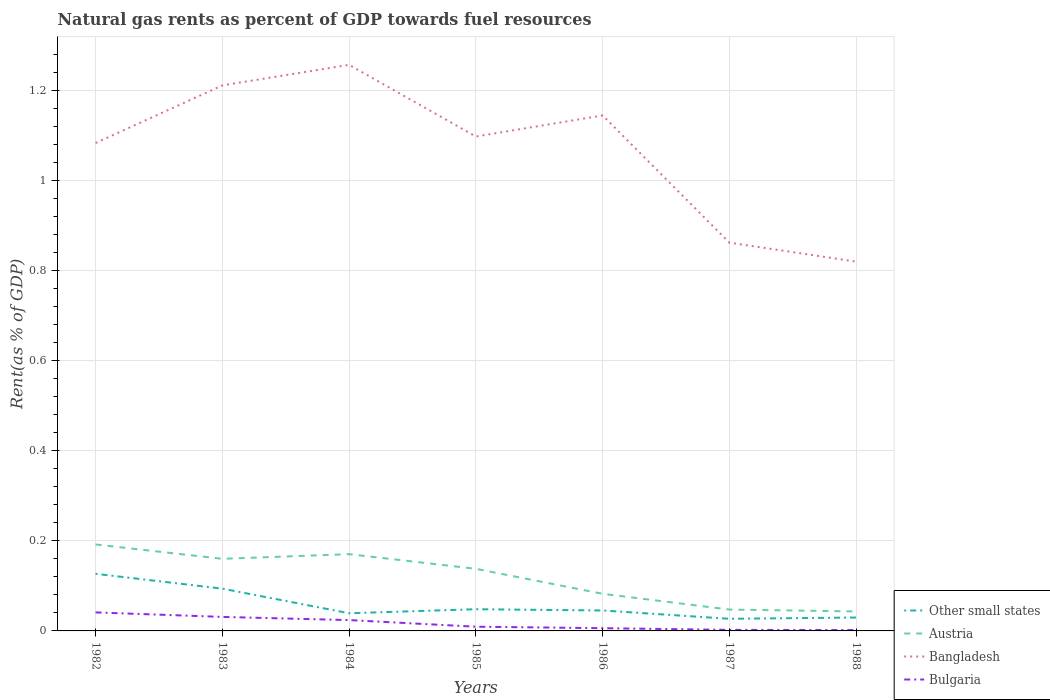Does the line corresponding to Austria intersect with the line corresponding to Bulgaria?
Ensure brevity in your answer.  No. Is the number of lines equal to the number of legend labels?
Your answer should be very brief. Yes. Across all years, what is the maximum matural gas rent in Bulgaria?
Keep it short and to the point. 0. What is the total matural gas rent in Bulgaria in the graph?
Your response must be concise. 0. What is the difference between the highest and the second highest matural gas rent in Other small states?
Offer a very short reply. 0.1. What is the difference between the highest and the lowest matural gas rent in Bangladesh?
Provide a short and direct response. 5. How many lines are there?
Your answer should be compact. 4. Does the graph contain any zero values?
Your answer should be very brief. No. Does the graph contain grids?
Offer a very short reply. Yes. How many legend labels are there?
Your answer should be very brief. 4. What is the title of the graph?
Give a very brief answer. Natural gas rents as percent of GDP towards fuel resources. What is the label or title of the Y-axis?
Ensure brevity in your answer.  Rent(as % of GDP). What is the Rent(as % of GDP) of Other small states in 1982?
Ensure brevity in your answer.  0.13. What is the Rent(as % of GDP) of Austria in 1982?
Provide a succinct answer. 0.19. What is the Rent(as % of GDP) of Bangladesh in 1982?
Offer a very short reply. 1.08. What is the Rent(as % of GDP) of Bulgaria in 1982?
Offer a terse response. 0.04. What is the Rent(as % of GDP) of Other small states in 1983?
Your answer should be very brief. 0.09. What is the Rent(as % of GDP) of Austria in 1983?
Ensure brevity in your answer.  0.16. What is the Rent(as % of GDP) in Bangladesh in 1983?
Keep it short and to the point. 1.21. What is the Rent(as % of GDP) in Bulgaria in 1983?
Keep it short and to the point. 0.03. What is the Rent(as % of GDP) of Other small states in 1984?
Offer a very short reply. 0.04. What is the Rent(as % of GDP) in Austria in 1984?
Provide a succinct answer. 0.17. What is the Rent(as % of GDP) of Bangladesh in 1984?
Your response must be concise. 1.26. What is the Rent(as % of GDP) in Bulgaria in 1984?
Provide a succinct answer. 0.02. What is the Rent(as % of GDP) in Other small states in 1985?
Provide a succinct answer. 0.05. What is the Rent(as % of GDP) of Austria in 1985?
Make the answer very short. 0.14. What is the Rent(as % of GDP) in Bangladesh in 1985?
Keep it short and to the point. 1.1. What is the Rent(as % of GDP) of Bulgaria in 1985?
Ensure brevity in your answer.  0.01. What is the Rent(as % of GDP) in Other small states in 1986?
Your response must be concise. 0.05. What is the Rent(as % of GDP) of Austria in 1986?
Offer a terse response. 0.08. What is the Rent(as % of GDP) of Bangladesh in 1986?
Provide a succinct answer. 1.14. What is the Rent(as % of GDP) of Bulgaria in 1986?
Your answer should be compact. 0.01. What is the Rent(as % of GDP) of Other small states in 1987?
Offer a terse response. 0.03. What is the Rent(as % of GDP) in Austria in 1987?
Keep it short and to the point. 0.05. What is the Rent(as % of GDP) of Bangladesh in 1987?
Your answer should be compact. 0.86. What is the Rent(as % of GDP) of Bulgaria in 1987?
Keep it short and to the point. 0. What is the Rent(as % of GDP) in Other small states in 1988?
Your answer should be compact. 0.03. What is the Rent(as % of GDP) of Austria in 1988?
Your answer should be compact. 0.04. What is the Rent(as % of GDP) of Bangladesh in 1988?
Offer a terse response. 0.82. What is the Rent(as % of GDP) of Bulgaria in 1988?
Offer a very short reply. 0. Across all years, what is the maximum Rent(as % of GDP) in Other small states?
Your response must be concise. 0.13. Across all years, what is the maximum Rent(as % of GDP) in Austria?
Offer a terse response. 0.19. Across all years, what is the maximum Rent(as % of GDP) of Bangladesh?
Offer a very short reply. 1.26. Across all years, what is the maximum Rent(as % of GDP) of Bulgaria?
Your answer should be very brief. 0.04. Across all years, what is the minimum Rent(as % of GDP) in Other small states?
Give a very brief answer. 0.03. Across all years, what is the minimum Rent(as % of GDP) of Austria?
Provide a short and direct response. 0.04. Across all years, what is the minimum Rent(as % of GDP) in Bangladesh?
Offer a terse response. 0.82. Across all years, what is the minimum Rent(as % of GDP) in Bulgaria?
Make the answer very short. 0. What is the total Rent(as % of GDP) of Other small states in the graph?
Give a very brief answer. 0.41. What is the total Rent(as % of GDP) in Austria in the graph?
Keep it short and to the point. 0.83. What is the total Rent(as % of GDP) in Bangladesh in the graph?
Your response must be concise. 7.47. What is the total Rent(as % of GDP) in Bulgaria in the graph?
Offer a very short reply. 0.12. What is the difference between the Rent(as % of GDP) in Other small states in 1982 and that in 1983?
Your response must be concise. 0.03. What is the difference between the Rent(as % of GDP) of Austria in 1982 and that in 1983?
Give a very brief answer. 0.03. What is the difference between the Rent(as % of GDP) of Bangladesh in 1982 and that in 1983?
Your answer should be very brief. -0.13. What is the difference between the Rent(as % of GDP) of Other small states in 1982 and that in 1984?
Ensure brevity in your answer.  0.09. What is the difference between the Rent(as % of GDP) in Austria in 1982 and that in 1984?
Your answer should be compact. 0.02. What is the difference between the Rent(as % of GDP) of Bangladesh in 1982 and that in 1984?
Offer a terse response. -0.17. What is the difference between the Rent(as % of GDP) of Bulgaria in 1982 and that in 1984?
Provide a succinct answer. 0.02. What is the difference between the Rent(as % of GDP) in Other small states in 1982 and that in 1985?
Provide a short and direct response. 0.08. What is the difference between the Rent(as % of GDP) in Austria in 1982 and that in 1985?
Ensure brevity in your answer.  0.05. What is the difference between the Rent(as % of GDP) of Bangladesh in 1982 and that in 1985?
Give a very brief answer. -0.01. What is the difference between the Rent(as % of GDP) in Bulgaria in 1982 and that in 1985?
Your answer should be compact. 0.03. What is the difference between the Rent(as % of GDP) in Other small states in 1982 and that in 1986?
Give a very brief answer. 0.08. What is the difference between the Rent(as % of GDP) of Austria in 1982 and that in 1986?
Your response must be concise. 0.11. What is the difference between the Rent(as % of GDP) of Bangladesh in 1982 and that in 1986?
Make the answer very short. -0.06. What is the difference between the Rent(as % of GDP) in Bulgaria in 1982 and that in 1986?
Your answer should be compact. 0.04. What is the difference between the Rent(as % of GDP) in Other small states in 1982 and that in 1987?
Your answer should be compact. 0.1. What is the difference between the Rent(as % of GDP) of Austria in 1982 and that in 1987?
Your answer should be very brief. 0.14. What is the difference between the Rent(as % of GDP) in Bangladesh in 1982 and that in 1987?
Make the answer very short. 0.22. What is the difference between the Rent(as % of GDP) in Bulgaria in 1982 and that in 1987?
Your answer should be compact. 0.04. What is the difference between the Rent(as % of GDP) of Other small states in 1982 and that in 1988?
Provide a succinct answer. 0.1. What is the difference between the Rent(as % of GDP) of Austria in 1982 and that in 1988?
Offer a very short reply. 0.15. What is the difference between the Rent(as % of GDP) in Bangladesh in 1982 and that in 1988?
Offer a very short reply. 0.26. What is the difference between the Rent(as % of GDP) of Bulgaria in 1982 and that in 1988?
Offer a very short reply. 0.04. What is the difference between the Rent(as % of GDP) in Other small states in 1983 and that in 1984?
Your answer should be compact. 0.05. What is the difference between the Rent(as % of GDP) of Austria in 1983 and that in 1984?
Ensure brevity in your answer.  -0.01. What is the difference between the Rent(as % of GDP) of Bangladesh in 1983 and that in 1984?
Offer a very short reply. -0.05. What is the difference between the Rent(as % of GDP) of Bulgaria in 1983 and that in 1984?
Offer a very short reply. 0.01. What is the difference between the Rent(as % of GDP) of Other small states in 1983 and that in 1985?
Give a very brief answer. 0.05. What is the difference between the Rent(as % of GDP) in Austria in 1983 and that in 1985?
Give a very brief answer. 0.02. What is the difference between the Rent(as % of GDP) of Bangladesh in 1983 and that in 1985?
Keep it short and to the point. 0.11. What is the difference between the Rent(as % of GDP) in Bulgaria in 1983 and that in 1985?
Keep it short and to the point. 0.02. What is the difference between the Rent(as % of GDP) in Other small states in 1983 and that in 1986?
Provide a succinct answer. 0.05. What is the difference between the Rent(as % of GDP) in Austria in 1983 and that in 1986?
Give a very brief answer. 0.08. What is the difference between the Rent(as % of GDP) of Bangladesh in 1983 and that in 1986?
Provide a short and direct response. 0.07. What is the difference between the Rent(as % of GDP) of Bulgaria in 1983 and that in 1986?
Ensure brevity in your answer.  0.03. What is the difference between the Rent(as % of GDP) in Other small states in 1983 and that in 1987?
Offer a terse response. 0.07. What is the difference between the Rent(as % of GDP) of Austria in 1983 and that in 1987?
Offer a very short reply. 0.11. What is the difference between the Rent(as % of GDP) of Bangladesh in 1983 and that in 1987?
Your answer should be compact. 0.35. What is the difference between the Rent(as % of GDP) in Bulgaria in 1983 and that in 1987?
Make the answer very short. 0.03. What is the difference between the Rent(as % of GDP) of Other small states in 1983 and that in 1988?
Make the answer very short. 0.06. What is the difference between the Rent(as % of GDP) in Austria in 1983 and that in 1988?
Make the answer very short. 0.12. What is the difference between the Rent(as % of GDP) in Bangladesh in 1983 and that in 1988?
Keep it short and to the point. 0.39. What is the difference between the Rent(as % of GDP) of Bulgaria in 1983 and that in 1988?
Offer a terse response. 0.03. What is the difference between the Rent(as % of GDP) of Other small states in 1984 and that in 1985?
Your answer should be very brief. -0.01. What is the difference between the Rent(as % of GDP) of Austria in 1984 and that in 1985?
Give a very brief answer. 0.03. What is the difference between the Rent(as % of GDP) in Bangladesh in 1984 and that in 1985?
Ensure brevity in your answer.  0.16. What is the difference between the Rent(as % of GDP) of Bulgaria in 1984 and that in 1985?
Offer a terse response. 0.01. What is the difference between the Rent(as % of GDP) in Other small states in 1984 and that in 1986?
Provide a succinct answer. -0.01. What is the difference between the Rent(as % of GDP) of Austria in 1984 and that in 1986?
Your answer should be compact. 0.09. What is the difference between the Rent(as % of GDP) of Bangladesh in 1984 and that in 1986?
Your answer should be very brief. 0.11. What is the difference between the Rent(as % of GDP) in Bulgaria in 1984 and that in 1986?
Your answer should be compact. 0.02. What is the difference between the Rent(as % of GDP) of Other small states in 1984 and that in 1987?
Keep it short and to the point. 0.01. What is the difference between the Rent(as % of GDP) in Austria in 1984 and that in 1987?
Provide a short and direct response. 0.12. What is the difference between the Rent(as % of GDP) of Bangladesh in 1984 and that in 1987?
Your answer should be very brief. 0.39. What is the difference between the Rent(as % of GDP) in Bulgaria in 1984 and that in 1987?
Make the answer very short. 0.02. What is the difference between the Rent(as % of GDP) in Other small states in 1984 and that in 1988?
Make the answer very short. 0.01. What is the difference between the Rent(as % of GDP) in Austria in 1984 and that in 1988?
Make the answer very short. 0.13. What is the difference between the Rent(as % of GDP) in Bangladesh in 1984 and that in 1988?
Keep it short and to the point. 0.44. What is the difference between the Rent(as % of GDP) of Bulgaria in 1984 and that in 1988?
Give a very brief answer. 0.02. What is the difference between the Rent(as % of GDP) of Other small states in 1985 and that in 1986?
Keep it short and to the point. 0. What is the difference between the Rent(as % of GDP) in Austria in 1985 and that in 1986?
Your answer should be very brief. 0.06. What is the difference between the Rent(as % of GDP) of Bangladesh in 1985 and that in 1986?
Offer a terse response. -0.05. What is the difference between the Rent(as % of GDP) of Bulgaria in 1985 and that in 1986?
Provide a short and direct response. 0. What is the difference between the Rent(as % of GDP) of Other small states in 1985 and that in 1987?
Keep it short and to the point. 0.02. What is the difference between the Rent(as % of GDP) in Austria in 1985 and that in 1987?
Provide a short and direct response. 0.09. What is the difference between the Rent(as % of GDP) of Bangladesh in 1985 and that in 1987?
Your answer should be compact. 0.24. What is the difference between the Rent(as % of GDP) of Bulgaria in 1985 and that in 1987?
Provide a short and direct response. 0.01. What is the difference between the Rent(as % of GDP) in Other small states in 1985 and that in 1988?
Your answer should be compact. 0.02. What is the difference between the Rent(as % of GDP) of Austria in 1985 and that in 1988?
Make the answer very short. 0.09. What is the difference between the Rent(as % of GDP) in Bangladesh in 1985 and that in 1988?
Provide a short and direct response. 0.28. What is the difference between the Rent(as % of GDP) in Bulgaria in 1985 and that in 1988?
Your response must be concise. 0.01. What is the difference between the Rent(as % of GDP) of Other small states in 1986 and that in 1987?
Make the answer very short. 0.02. What is the difference between the Rent(as % of GDP) in Austria in 1986 and that in 1987?
Your response must be concise. 0.04. What is the difference between the Rent(as % of GDP) of Bangladesh in 1986 and that in 1987?
Your answer should be very brief. 0.28. What is the difference between the Rent(as % of GDP) in Bulgaria in 1986 and that in 1987?
Ensure brevity in your answer.  0. What is the difference between the Rent(as % of GDP) in Other small states in 1986 and that in 1988?
Your answer should be compact. 0.02. What is the difference between the Rent(as % of GDP) in Austria in 1986 and that in 1988?
Your answer should be very brief. 0.04. What is the difference between the Rent(as % of GDP) in Bangladesh in 1986 and that in 1988?
Your answer should be compact. 0.32. What is the difference between the Rent(as % of GDP) in Bulgaria in 1986 and that in 1988?
Ensure brevity in your answer.  0. What is the difference between the Rent(as % of GDP) in Other small states in 1987 and that in 1988?
Ensure brevity in your answer.  -0. What is the difference between the Rent(as % of GDP) in Austria in 1987 and that in 1988?
Your response must be concise. 0. What is the difference between the Rent(as % of GDP) of Bangladesh in 1987 and that in 1988?
Ensure brevity in your answer.  0.04. What is the difference between the Rent(as % of GDP) of Bulgaria in 1987 and that in 1988?
Your response must be concise. 0. What is the difference between the Rent(as % of GDP) of Other small states in 1982 and the Rent(as % of GDP) of Austria in 1983?
Give a very brief answer. -0.03. What is the difference between the Rent(as % of GDP) of Other small states in 1982 and the Rent(as % of GDP) of Bangladesh in 1983?
Offer a terse response. -1.08. What is the difference between the Rent(as % of GDP) in Other small states in 1982 and the Rent(as % of GDP) in Bulgaria in 1983?
Ensure brevity in your answer.  0.1. What is the difference between the Rent(as % of GDP) in Austria in 1982 and the Rent(as % of GDP) in Bangladesh in 1983?
Keep it short and to the point. -1.02. What is the difference between the Rent(as % of GDP) in Austria in 1982 and the Rent(as % of GDP) in Bulgaria in 1983?
Make the answer very short. 0.16. What is the difference between the Rent(as % of GDP) of Bangladesh in 1982 and the Rent(as % of GDP) of Bulgaria in 1983?
Offer a very short reply. 1.05. What is the difference between the Rent(as % of GDP) in Other small states in 1982 and the Rent(as % of GDP) in Austria in 1984?
Your response must be concise. -0.04. What is the difference between the Rent(as % of GDP) in Other small states in 1982 and the Rent(as % of GDP) in Bangladesh in 1984?
Make the answer very short. -1.13. What is the difference between the Rent(as % of GDP) in Other small states in 1982 and the Rent(as % of GDP) in Bulgaria in 1984?
Your answer should be very brief. 0.1. What is the difference between the Rent(as % of GDP) in Austria in 1982 and the Rent(as % of GDP) in Bangladesh in 1984?
Keep it short and to the point. -1.06. What is the difference between the Rent(as % of GDP) of Austria in 1982 and the Rent(as % of GDP) of Bulgaria in 1984?
Ensure brevity in your answer.  0.17. What is the difference between the Rent(as % of GDP) in Bangladesh in 1982 and the Rent(as % of GDP) in Bulgaria in 1984?
Offer a terse response. 1.06. What is the difference between the Rent(as % of GDP) in Other small states in 1982 and the Rent(as % of GDP) in Austria in 1985?
Offer a terse response. -0.01. What is the difference between the Rent(as % of GDP) of Other small states in 1982 and the Rent(as % of GDP) of Bangladesh in 1985?
Offer a very short reply. -0.97. What is the difference between the Rent(as % of GDP) in Other small states in 1982 and the Rent(as % of GDP) in Bulgaria in 1985?
Your answer should be compact. 0.12. What is the difference between the Rent(as % of GDP) in Austria in 1982 and the Rent(as % of GDP) in Bangladesh in 1985?
Give a very brief answer. -0.91. What is the difference between the Rent(as % of GDP) of Austria in 1982 and the Rent(as % of GDP) of Bulgaria in 1985?
Your answer should be compact. 0.18. What is the difference between the Rent(as % of GDP) in Bangladesh in 1982 and the Rent(as % of GDP) in Bulgaria in 1985?
Give a very brief answer. 1.07. What is the difference between the Rent(as % of GDP) of Other small states in 1982 and the Rent(as % of GDP) of Austria in 1986?
Your response must be concise. 0.04. What is the difference between the Rent(as % of GDP) in Other small states in 1982 and the Rent(as % of GDP) in Bangladesh in 1986?
Offer a terse response. -1.02. What is the difference between the Rent(as % of GDP) in Other small states in 1982 and the Rent(as % of GDP) in Bulgaria in 1986?
Keep it short and to the point. 0.12. What is the difference between the Rent(as % of GDP) of Austria in 1982 and the Rent(as % of GDP) of Bangladesh in 1986?
Keep it short and to the point. -0.95. What is the difference between the Rent(as % of GDP) of Austria in 1982 and the Rent(as % of GDP) of Bulgaria in 1986?
Offer a very short reply. 0.19. What is the difference between the Rent(as % of GDP) of Bangladesh in 1982 and the Rent(as % of GDP) of Bulgaria in 1986?
Make the answer very short. 1.08. What is the difference between the Rent(as % of GDP) of Other small states in 1982 and the Rent(as % of GDP) of Austria in 1987?
Your answer should be compact. 0.08. What is the difference between the Rent(as % of GDP) in Other small states in 1982 and the Rent(as % of GDP) in Bangladesh in 1987?
Offer a terse response. -0.73. What is the difference between the Rent(as % of GDP) in Other small states in 1982 and the Rent(as % of GDP) in Bulgaria in 1987?
Your response must be concise. 0.12. What is the difference between the Rent(as % of GDP) in Austria in 1982 and the Rent(as % of GDP) in Bangladesh in 1987?
Keep it short and to the point. -0.67. What is the difference between the Rent(as % of GDP) of Austria in 1982 and the Rent(as % of GDP) of Bulgaria in 1987?
Offer a very short reply. 0.19. What is the difference between the Rent(as % of GDP) in Bangladesh in 1982 and the Rent(as % of GDP) in Bulgaria in 1987?
Keep it short and to the point. 1.08. What is the difference between the Rent(as % of GDP) of Other small states in 1982 and the Rent(as % of GDP) of Austria in 1988?
Make the answer very short. 0.08. What is the difference between the Rent(as % of GDP) in Other small states in 1982 and the Rent(as % of GDP) in Bangladesh in 1988?
Offer a terse response. -0.69. What is the difference between the Rent(as % of GDP) of Other small states in 1982 and the Rent(as % of GDP) of Bulgaria in 1988?
Offer a very short reply. 0.12. What is the difference between the Rent(as % of GDP) in Austria in 1982 and the Rent(as % of GDP) in Bangladesh in 1988?
Offer a terse response. -0.63. What is the difference between the Rent(as % of GDP) in Austria in 1982 and the Rent(as % of GDP) in Bulgaria in 1988?
Provide a short and direct response. 0.19. What is the difference between the Rent(as % of GDP) of Bangladesh in 1982 and the Rent(as % of GDP) of Bulgaria in 1988?
Offer a very short reply. 1.08. What is the difference between the Rent(as % of GDP) of Other small states in 1983 and the Rent(as % of GDP) of Austria in 1984?
Provide a short and direct response. -0.08. What is the difference between the Rent(as % of GDP) of Other small states in 1983 and the Rent(as % of GDP) of Bangladesh in 1984?
Your answer should be compact. -1.16. What is the difference between the Rent(as % of GDP) of Other small states in 1983 and the Rent(as % of GDP) of Bulgaria in 1984?
Your answer should be compact. 0.07. What is the difference between the Rent(as % of GDP) of Austria in 1983 and the Rent(as % of GDP) of Bangladesh in 1984?
Keep it short and to the point. -1.1. What is the difference between the Rent(as % of GDP) of Austria in 1983 and the Rent(as % of GDP) of Bulgaria in 1984?
Make the answer very short. 0.14. What is the difference between the Rent(as % of GDP) of Bangladesh in 1983 and the Rent(as % of GDP) of Bulgaria in 1984?
Keep it short and to the point. 1.19. What is the difference between the Rent(as % of GDP) in Other small states in 1983 and the Rent(as % of GDP) in Austria in 1985?
Ensure brevity in your answer.  -0.04. What is the difference between the Rent(as % of GDP) in Other small states in 1983 and the Rent(as % of GDP) in Bangladesh in 1985?
Provide a succinct answer. -1. What is the difference between the Rent(as % of GDP) in Other small states in 1983 and the Rent(as % of GDP) in Bulgaria in 1985?
Make the answer very short. 0.08. What is the difference between the Rent(as % of GDP) of Austria in 1983 and the Rent(as % of GDP) of Bangladesh in 1985?
Ensure brevity in your answer.  -0.94. What is the difference between the Rent(as % of GDP) in Austria in 1983 and the Rent(as % of GDP) in Bulgaria in 1985?
Your answer should be very brief. 0.15. What is the difference between the Rent(as % of GDP) of Bangladesh in 1983 and the Rent(as % of GDP) of Bulgaria in 1985?
Your answer should be very brief. 1.2. What is the difference between the Rent(as % of GDP) of Other small states in 1983 and the Rent(as % of GDP) of Austria in 1986?
Keep it short and to the point. 0.01. What is the difference between the Rent(as % of GDP) in Other small states in 1983 and the Rent(as % of GDP) in Bangladesh in 1986?
Your answer should be very brief. -1.05. What is the difference between the Rent(as % of GDP) in Other small states in 1983 and the Rent(as % of GDP) in Bulgaria in 1986?
Your answer should be compact. 0.09. What is the difference between the Rent(as % of GDP) in Austria in 1983 and the Rent(as % of GDP) in Bangladesh in 1986?
Provide a short and direct response. -0.98. What is the difference between the Rent(as % of GDP) of Austria in 1983 and the Rent(as % of GDP) of Bulgaria in 1986?
Your answer should be compact. 0.15. What is the difference between the Rent(as % of GDP) of Bangladesh in 1983 and the Rent(as % of GDP) of Bulgaria in 1986?
Your answer should be compact. 1.2. What is the difference between the Rent(as % of GDP) of Other small states in 1983 and the Rent(as % of GDP) of Austria in 1987?
Ensure brevity in your answer.  0.05. What is the difference between the Rent(as % of GDP) in Other small states in 1983 and the Rent(as % of GDP) in Bangladesh in 1987?
Ensure brevity in your answer.  -0.77. What is the difference between the Rent(as % of GDP) of Other small states in 1983 and the Rent(as % of GDP) of Bulgaria in 1987?
Your response must be concise. 0.09. What is the difference between the Rent(as % of GDP) of Austria in 1983 and the Rent(as % of GDP) of Bangladesh in 1987?
Give a very brief answer. -0.7. What is the difference between the Rent(as % of GDP) of Austria in 1983 and the Rent(as % of GDP) of Bulgaria in 1987?
Your answer should be very brief. 0.16. What is the difference between the Rent(as % of GDP) in Bangladesh in 1983 and the Rent(as % of GDP) in Bulgaria in 1987?
Provide a succinct answer. 1.21. What is the difference between the Rent(as % of GDP) of Other small states in 1983 and the Rent(as % of GDP) of Austria in 1988?
Ensure brevity in your answer.  0.05. What is the difference between the Rent(as % of GDP) in Other small states in 1983 and the Rent(as % of GDP) in Bangladesh in 1988?
Your response must be concise. -0.73. What is the difference between the Rent(as % of GDP) of Other small states in 1983 and the Rent(as % of GDP) of Bulgaria in 1988?
Provide a succinct answer. 0.09. What is the difference between the Rent(as % of GDP) of Austria in 1983 and the Rent(as % of GDP) of Bangladesh in 1988?
Your answer should be very brief. -0.66. What is the difference between the Rent(as % of GDP) of Austria in 1983 and the Rent(as % of GDP) of Bulgaria in 1988?
Provide a short and direct response. 0.16. What is the difference between the Rent(as % of GDP) in Bangladesh in 1983 and the Rent(as % of GDP) in Bulgaria in 1988?
Keep it short and to the point. 1.21. What is the difference between the Rent(as % of GDP) of Other small states in 1984 and the Rent(as % of GDP) of Austria in 1985?
Give a very brief answer. -0.1. What is the difference between the Rent(as % of GDP) of Other small states in 1984 and the Rent(as % of GDP) of Bangladesh in 1985?
Your answer should be compact. -1.06. What is the difference between the Rent(as % of GDP) in Other small states in 1984 and the Rent(as % of GDP) in Bulgaria in 1985?
Offer a terse response. 0.03. What is the difference between the Rent(as % of GDP) of Austria in 1984 and the Rent(as % of GDP) of Bangladesh in 1985?
Offer a very short reply. -0.93. What is the difference between the Rent(as % of GDP) in Austria in 1984 and the Rent(as % of GDP) in Bulgaria in 1985?
Provide a short and direct response. 0.16. What is the difference between the Rent(as % of GDP) of Bangladesh in 1984 and the Rent(as % of GDP) of Bulgaria in 1985?
Make the answer very short. 1.25. What is the difference between the Rent(as % of GDP) in Other small states in 1984 and the Rent(as % of GDP) in Austria in 1986?
Provide a succinct answer. -0.04. What is the difference between the Rent(as % of GDP) of Other small states in 1984 and the Rent(as % of GDP) of Bangladesh in 1986?
Your response must be concise. -1.1. What is the difference between the Rent(as % of GDP) of Other small states in 1984 and the Rent(as % of GDP) of Bulgaria in 1986?
Ensure brevity in your answer.  0.03. What is the difference between the Rent(as % of GDP) of Austria in 1984 and the Rent(as % of GDP) of Bangladesh in 1986?
Make the answer very short. -0.97. What is the difference between the Rent(as % of GDP) of Austria in 1984 and the Rent(as % of GDP) of Bulgaria in 1986?
Make the answer very short. 0.16. What is the difference between the Rent(as % of GDP) of Other small states in 1984 and the Rent(as % of GDP) of Austria in 1987?
Give a very brief answer. -0.01. What is the difference between the Rent(as % of GDP) of Other small states in 1984 and the Rent(as % of GDP) of Bangladesh in 1987?
Give a very brief answer. -0.82. What is the difference between the Rent(as % of GDP) in Other small states in 1984 and the Rent(as % of GDP) in Bulgaria in 1987?
Make the answer very short. 0.04. What is the difference between the Rent(as % of GDP) of Austria in 1984 and the Rent(as % of GDP) of Bangladesh in 1987?
Your answer should be very brief. -0.69. What is the difference between the Rent(as % of GDP) of Austria in 1984 and the Rent(as % of GDP) of Bulgaria in 1987?
Make the answer very short. 0.17. What is the difference between the Rent(as % of GDP) in Bangladesh in 1984 and the Rent(as % of GDP) in Bulgaria in 1987?
Offer a terse response. 1.25. What is the difference between the Rent(as % of GDP) in Other small states in 1984 and the Rent(as % of GDP) in Austria in 1988?
Ensure brevity in your answer.  -0. What is the difference between the Rent(as % of GDP) in Other small states in 1984 and the Rent(as % of GDP) in Bangladesh in 1988?
Provide a succinct answer. -0.78. What is the difference between the Rent(as % of GDP) in Other small states in 1984 and the Rent(as % of GDP) in Bulgaria in 1988?
Provide a short and direct response. 0.04. What is the difference between the Rent(as % of GDP) in Austria in 1984 and the Rent(as % of GDP) in Bangladesh in 1988?
Provide a short and direct response. -0.65. What is the difference between the Rent(as % of GDP) in Austria in 1984 and the Rent(as % of GDP) in Bulgaria in 1988?
Provide a short and direct response. 0.17. What is the difference between the Rent(as % of GDP) of Bangladesh in 1984 and the Rent(as % of GDP) of Bulgaria in 1988?
Your answer should be compact. 1.25. What is the difference between the Rent(as % of GDP) of Other small states in 1985 and the Rent(as % of GDP) of Austria in 1986?
Keep it short and to the point. -0.03. What is the difference between the Rent(as % of GDP) in Other small states in 1985 and the Rent(as % of GDP) in Bangladesh in 1986?
Your answer should be very brief. -1.1. What is the difference between the Rent(as % of GDP) of Other small states in 1985 and the Rent(as % of GDP) of Bulgaria in 1986?
Your response must be concise. 0.04. What is the difference between the Rent(as % of GDP) of Austria in 1985 and the Rent(as % of GDP) of Bangladesh in 1986?
Make the answer very short. -1.01. What is the difference between the Rent(as % of GDP) in Austria in 1985 and the Rent(as % of GDP) in Bulgaria in 1986?
Your answer should be compact. 0.13. What is the difference between the Rent(as % of GDP) in Bangladesh in 1985 and the Rent(as % of GDP) in Bulgaria in 1986?
Make the answer very short. 1.09. What is the difference between the Rent(as % of GDP) of Other small states in 1985 and the Rent(as % of GDP) of Austria in 1987?
Offer a terse response. 0. What is the difference between the Rent(as % of GDP) of Other small states in 1985 and the Rent(as % of GDP) of Bangladesh in 1987?
Keep it short and to the point. -0.81. What is the difference between the Rent(as % of GDP) in Other small states in 1985 and the Rent(as % of GDP) in Bulgaria in 1987?
Ensure brevity in your answer.  0.05. What is the difference between the Rent(as % of GDP) in Austria in 1985 and the Rent(as % of GDP) in Bangladesh in 1987?
Your answer should be very brief. -0.72. What is the difference between the Rent(as % of GDP) in Austria in 1985 and the Rent(as % of GDP) in Bulgaria in 1987?
Provide a succinct answer. 0.14. What is the difference between the Rent(as % of GDP) in Bangladesh in 1985 and the Rent(as % of GDP) in Bulgaria in 1987?
Your response must be concise. 1.09. What is the difference between the Rent(as % of GDP) in Other small states in 1985 and the Rent(as % of GDP) in Austria in 1988?
Give a very brief answer. 0. What is the difference between the Rent(as % of GDP) in Other small states in 1985 and the Rent(as % of GDP) in Bangladesh in 1988?
Give a very brief answer. -0.77. What is the difference between the Rent(as % of GDP) of Other small states in 1985 and the Rent(as % of GDP) of Bulgaria in 1988?
Keep it short and to the point. 0.05. What is the difference between the Rent(as % of GDP) of Austria in 1985 and the Rent(as % of GDP) of Bangladesh in 1988?
Give a very brief answer. -0.68. What is the difference between the Rent(as % of GDP) in Austria in 1985 and the Rent(as % of GDP) in Bulgaria in 1988?
Offer a very short reply. 0.14. What is the difference between the Rent(as % of GDP) of Bangladesh in 1985 and the Rent(as % of GDP) of Bulgaria in 1988?
Offer a terse response. 1.1. What is the difference between the Rent(as % of GDP) in Other small states in 1986 and the Rent(as % of GDP) in Austria in 1987?
Make the answer very short. -0. What is the difference between the Rent(as % of GDP) in Other small states in 1986 and the Rent(as % of GDP) in Bangladesh in 1987?
Ensure brevity in your answer.  -0.82. What is the difference between the Rent(as % of GDP) of Other small states in 1986 and the Rent(as % of GDP) of Bulgaria in 1987?
Your answer should be compact. 0.04. What is the difference between the Rent(as % of GDP) of Austria in 1986 and the Rent(as % of GDP) of Bangladesh in 1987?
Offer a terse response. -0.78. What is the difference between the Rent(as % of GDP) in Austria in 1986 and the Rent(as % of GDP) in Bulgaria in 1987?
Give a very brief answer. 0.08. What is the difference between the Rent(as % of GDP) of Bangladesh in 1986 and the Rent(as % of GDP) of Bulgaria in 1987?
Your answer should be compact. 1.14. What is the difference between the Rent(as % of GDP) of Other small states in 1986 and the Rent(as % of GDP) of Austria in 1988?
Your answer should be very brief. 0. What is the difference between the Rent(as % of GDP) in Other small states in 1986 and the Rent(as % of GDP) in Bangladesh in 1988?
Your response must be concise. -0.77. What is the difference between the Rent(as % of GDP) of Other small states in 1986 and the Rent(as % of GDP) of Bulgaria in 1988?
Your answer should be compact. 0.04. What is the difference between the Rent(as % of GDP) of Austria in 1986 and the Rent(as % of GDP) of Bangladesh in 1988?
Ensure brevity in your answer.  -0.74. What is the difference between the Rent(as % of GDP) in Austria in 1986 and the Rent(as % of GDP) in Bulgaria in 1988?
Your response must be concise. 0.08. What is the difference between the Rent(as % of GDP) in Bangladesh in 1986 and the Rent(as % of GDP) in Bulgaria in 1988?
Ensure brevity in your answer.  1.14. What is the difference between the Rent(as % of GDP) of Other small states in 1987 and the Rent(as % of GDP) of Austria in 1988?
Offer a terse response. -0.02. What is the difference between the Rent(as % of GDP) in Other small states in 1987 and the Rent(as % of GDP) in Bangladesh in 1988?
Your response must be concise. -0.79. What is the difference between the Rent(as % of GDP) of Other small states in 1987 and the Rent(as % of GDP) of Bulgaria in 1988?
Your response must be concise. 0.03. What is the difference between the Rent(as % of GDP) of Austria in 1987 and the Rent(as % of GDP) of Bangladesh in 1988?
Your answer should be very brief. -0.77. What is the difference between the Rent(as % of GDP) in Austria in 1987 and the Rent(as % of GDP) in Bulgaria in 1988?
Keep it short and to the point. 0.05. What is the difference between the Rent(as % of GDP) in Bangladesh in 1987 and the Rent(as % of GDP) in Bulgaria in 1988?
Offer a terse response. 0.86. What is the average Rent(as % of GDP) in Other small states per year?
Your response must be concise. 0.06. What is the average Rent(as % of GDP) of Austria per year?
Offer a terse response. 0.12. What is the average Rent(as % of GDP) of Bangladesh per year?
Make the answer very short. 1.07. What is the average Rent(as % of GDP) in Bulgaria per year?
Offer a terse response. 0.02. In the year 1982, what is the difference between the Rent(as % of GDP) in Other small states and Rent(as % of GDP) in Austria?
Provide a succinct answer. -0.07. In the year 1982, what is the difference between the Rent(as % of GDP) of Other small states and Rent(as % of GDP) of Bangladesh?
Keep it short and to the point. -0.96. In the year 1982, what is the difference between the Rent(as % of GDP) of Other small states and Rent(as % of GDP) of Bulgaria?
Your response must be concise. 0.09. In the year 1982, what is the difference between the Rent(as % of GDP) in Austria and Rent(as % of GDP) in Bangladesh?
Ensure brevity in your answer.  -0.89. In the year 1982, what is the difference between the Rent(as % of GDP) in Austria and Rent(as % of GDP) in Bulgaria?
Offer a terse response. 0.15. In the year 1982, what is the difference between the Rent(as % of GDP) in Bangladesh and Rent(as % of GDP) in Bulgaria?
Your response must be concise. 1.04. In the year 1983, what is the difference between the Rent(as % of GDP) in Other small states and Rent(as % of GDP) in Austria?
Your response must be concise. -0.07. In the year 1983, what is the difference between the Rent(as % of GDP) of Other small states and Rent(as % of GDP) of Bangladesh?
Provide a succinct answer. -1.12. In the year 1983, what is the difference between the Rent(as % of GDP) in Other small states and Rent(as % of GDP) in Bulgaria?
Your answer should be compact. 0.06. In the year 1983, what is the difference between the Rent(as % of GDP) of Austria and Rent(as % of GDP) of Bangladesh?
Make the answer very short. -1.05. In the year 1983, what is the difference between the Rent(as % of GDP) of Austria and Rent(as % of GDP) of Bulgaria?
Offer a terse response. 0.13. In the year 1983, what is the difference between the Rent(as % of GDP) of Bangladesh and Rent(as % of GDP) of Bulgaria?
Ensure brevity in your answer.  1.18. In the year 1984, what is the difference between the Rent(as % of GDP) of Other small states and Rent(as % of GDP) of Austria?
Your response must be concise. -0.13. In the year 1984, what is the difference between the Rent(as % of GDP) in Other small states and Rent(as % of GDP) in Bangladesh?
Provide a succinct answer. -1.22. In the year 1984, what is the difference between the Rent(as % of GDP) in Other small states and Rent(as % of GDP) in Bulgaria?
Your response must be concise. 0.02. In the year 1984, what is the difference between the Rent(as % of GDP) in Austria and Rent(as % of GDP) in Bangladesh?
Provide a succinct answer. -1.09. In the year 1984, what is the difference between the Rent(as % of GDP) of Austria and Rent(as % of GDP) of Bulgaria?
Ensure brevity in your answer.  0.15. In the year 1984, what is the difference between the Rent(as % of GDP) of Bangladesh and Rent(as % of GDP) of Bulgaria?
Give a very brief answer. 1.23. In the year 1985, what is the difference between the Rent(as % of GDP) in Other small states and Rent(as % of GDP) in Austria?
Provide a short and direct response. -0.09. In the year 1985, what is the difference between the Rent(as % of GDP) of Other small states and Rent(as % of GDP) of Bangladesh?
Keep it short and to the point. -1.05. In the year 1985, what is the difference between the Rent(as % of GDP) of Other small states and Rent(as % of GDP) of Bulgaria?
Keep it short and to the point. 0.04. In the year 1985, what is the difference between the Rent(as % of GDP) in Austria and Rent(as % of GDP) in Bangladesh?
Provide a succinct answer. -0.96. In the year 1985, what is the difference between the Rent(as % of GDP) in Austria and Rent(as % of GDP) in Bulgaria?
Your answer should be compact. 0.13. In the year 1985, what is the difference between the Rent(as % of GDP) in Bangladesh and Rent(as % of GDP) in Bulgaria?
Ensure brevity in your answer.  1.09. In the year 1986, what is the difference between the Rent(as % of GDP) of Other small states and Rent(as % of GDP) of Austria?
Offer a very short reply. -0.04. In the year 1986, what is the difference between the Rent(as % of GDP) in Other small states and Rent(as % of GDP) in Bangladesh?
Ensure brevity in your answer.  -1.1. In the year 1986, what is the difference between the Rent(as % of GDP) in Other small states and Rent(as % of GDP) in Bulgaria?
Make the answer very short. 0.04. In the year 1986, what is the difference between the Rent(as % of GDP) in Austria and Rent(as % of GDP) in Bangladesh?
Make the answer very short. -1.06. In the year 1986, what is the difference between the Rent(as % of GDP) in Austria and Rent(as % of GDP) in Bulgaria?
Provide a succinct answer. 0.08. In the year 1986, what is the difference between the Rent(as % of GDP) in Bangladesh and Rent(as % of GDP) in Bulgaria?
Offer a very short reply. 1.14. In the year 1987, what is the difference between the Rent(as % of GDP) of Other small states and Rent(as % of GDP) of Austria?
Your answer should be compact. -0.02. In the year 1987, what is the difference between the Rent(as % of GDP) in Other small states and Rent(as % of GDP) in Bangladesh?
Ensure brevity in your answer.  -0.83. In the year 1987, what is the difference between the Rent(as % of GDP) of Other small states and Rent(as % of GDP) of Bulgaria?
Provide a short and direct response. 0.02. In the year 1987, what is the difference between the Rent(as % of GDP) of Austria and Rent(as % of GDP) of Bangladesh?
Offer a terse response. -0.81. In the year 1987, what is the difference between the Rent(as % of GDP) of Austria and Rent(as % of GDP) of Bulgaria?
Your answer should be very brief. 0.05. In the year 1987, what is the difference between the Rent(as % of GDP) in Bangladesh and Rent(as % of GDP) in Bulgaria?
Your answer should be very brief. 0.86. In the year 1988, what is the difference between the Rent(as % of GDP) in Other small states and Rent(as % of GDP) in Austria?
Provide a succinct answer. -0.01. In the year 1988, what is the difference between the Rent(as % of GDP) of Other small states and Rent(as % of GDP) of Bangladesh?
Provide a short and direct response. -0.79. In the year 1988, what is the difference between the Rent(as % of GDP) in Other small states and Rent(as % of GDP) in Bulgaria?
Provide a succinct answer. 0.03. In the year 1988, what is the difference between the Rent(as % of GDP) of Austria and Rent(as % of GDP) of Bangladesh?
Your answer should be very brief. -0.78. In the year 1988, what is the difference between the Rent(as % of GDP) of Austria and Rent(as % of GDP) of Bulgaria?
Offer a very short reply. 0.04. In the year 1988, what is the difference between the Rent(as % of GDP) in Bangladesh and Rent(as % of GDP) in Bulgaria?
Your response must be concise. 0.82. What is the ratio of the Rent(as % of GDP) of Other small states in 1982 to that in 1983?
Keep it short and to the point. 1.35. What is the ratio of the Rent(as % of GDP) of Austria in 1982 to that in 1983?
Make the answer very short. 1.2. What is the ratio of the Rent(as % of GDP) of Bangladesh in 1982 to that in 1983?
Give a very brief answer. 0.89. What is the ratio of the Rent(as % of GDP) in Bulgaria in 1982 to that in 1983?
Your answer should be compact. 1.32. What is the ratio of the Rent(as % of GDP) in Other small states in 1982 to that in 1984?
Your response must be concise. 3.23. What is the ratio of the Rent(as % of GDP) in Austria in 1982 to that in 1984?
Your answer should be compact. 1.13. What is the ratio of the Rent(as % of GDP) of Bangladesh in 1982 to that in 1984?
Offer a terse response. 0.86. What is the ratio of the Rent(as % of GDP) of Bulgaria in 1982 to that in 1984?
Provide a succinct answer. 1.71. What is the ratio of the Rent(as % of GDP) of Other small states in 1982 to that in 1985?
Give a very brief answer. 2.63. What is the ratio of the Rent(as % of GDP) in Austria in 1982 to that in 1985?
Keep it short and to the point. 1.39. What is the ratio of the Rent(as % of GDP) of Bangladesh in 1982 to that in 1985?
Your answer should be compact. 0.99. What is the ratio of the Rent(as % of GDP) of Bulgaria in 1982 to that in 1985?
Ensure brevity in your answer.  4.39. What is the ratio of the Rent(as % of GDP) of Other small states in 1982 to that in 1986?
Offer a very short reply. 2.8. What is the ratio of the Rent(as % of GDP) in Austria in 1982 to that in 1986?
Provide a succinct answer. 2.33. What is the ratio of the Rent(as % of GDP) in Bangladesh in 1982 to that in 1986?
Make the answer very short. 0.95. What is the ratio of the Rent(as % of GDP) of Bulgaria in 1982 to that in 1986?
Keep it short and to the point. 6.78. What is the ratio of the Rent(as % of GDP) in Other small states in 1982 to that in 1987?
Your answer should be compact. 4.71. What is the ratio of the Rent(as % of GDP) in Austria in 1982 to that in 1987?
Make the answer very short. 4.05. What is the ratio of the Rent(as % of GDP) of Bangladesh in 1982 to that in 1987?
Ensure brevity in your answer.  1.26. What is the ratio of the Rent(as % of GDP) of Bulgaria in 1982 to that in 1987?
Provide a succinct answer. 17.65. What is the ratio of the Rent(as % of GDP) in Other small states in 1982 to that in 1988?
Your answer should be very brief. 4.26. What is the ratio of the Rent(as % of GDP) in Austria in 1982 to that in 1988?
Ensure brevity in your answer.  4.44. What is the ratio of the Rent(as % of GDP) of Bangladesh in 1982 to that in 1988?
Your response must be concise. 1.32. What is the ratio of the Rent(as % of GDP) in Bulgaria in 1982 to that in 1988?
Your answer should be compact. 21.04. What is the ratio of the Rent(as % of GDP) in Other small states in 1983 to that in 1984?
Your response must be concise. 2.39. What is the ratio of the Rent(as % of GDP) of Austria in 1983 to that in 1984?
Give a very brief answer. 0.94. What is the ratio of the Rent(as % of GDP) of Bangladesh in 1983 to that in 1984?
Offer a terse response. 0.96. What is the ratio of the Rent(as % of GDP) of Bulgaria in 1983 to that in 1984?
Ensure brevity in your answer.  1.29. What is the ratio of the Rent(as % of GDP) of Other small states in 1983 to that in 1985?
Offer a very short reply. 1.95. What is the ratio of the Rent(as % of GDP) of Austria in 1983 to that in 1985?
Your answer should be very brief. 1.16. What is the ratio of the Rent(as % of GDP) of Bangladesh in 1983 to that in 1985?
Your response must be concise. 1.1. What is the ratio of the Rent(as % of GDP) in Bulgaria in 1983 to that in 1985?
Make the answer very short. 3.32. What is the ratio of the Rent(as % of GDP) of Other small states in 1983 to that in 1986?
Your answer should be compact. 2.07. What is the ratio of the Rent(as % of GDP) in Austria in 1983 to that in 1986?
Keep it short and to the point. 1.94. What is the ratio of the Rent(as % of GDP) in Bangladesh in 1983 to that in 1986?
Your answer should be very brief. 1.06. What is the ratio of the Rent(as % of GDP) of Bulgaria in 1983 to that in 1986?
Provide a short and direct response. 5.13. What is the ratio of the Rent(as % of GDP) in Other small states in 1983 to that in 1987?
Give a very brief answer. 3.48. What is the ratio of the Rent(as % of GDP) in Austria in 1983 to that in 1987?
Ensure brevity in your answer.  3.38. What is the ratio of the Rent(as % of GDP) in Bangladesh in 1983 to that in 1987?
Make the answer very short. 1.41. What is the ratio of the Rent(as % of GDP) in Bulgaria in 1983 to that in 1987?
Offer a terse response. 13.36. What is the ratio of the Rent(as % of GDP) of Other small states in 1983 to that in 1988?
Give a very brief answer. 3.15. What is the ratio of the Rent(as % of GDP) of Austria in 1983 to that in 1988?
Ensure brevity in your answer.  3.7. What is the ratio of the Rent(as % of GDP) in Bangladesh in 1983 to that in 1988?
Ensure brevity in your answer.  1.48. What is the ratio of the Rent(as % of GDP) in Bulgaria in 1983 to that in 1988?
Make the answer very short. 15.93. What is the ratio of the Rent(as % of GDP) of Other small states in 1984 to that in 1985?
Your answer should be very brief. 0.81. What is the ratio of the Rent(as % of GDP) in Austria in 1984 to that in 1985?
Provide a succinct answer. 1.24. What is the ratio of the Rent(as % of GDP) in Bangladesh in 1984 to that in 1985?
Provide a short and direct response. 1.15. What is the ratio of the Rent(as % of GDP) in Bulgaria in 1984 to that in 1985?
Keep it short and to the point. 2.57. What is the ratio of the Rent(as % of GDP) of Other small states in 1984 to that in 1986?
Keep it short and to the point. 0.86. What is the ratio of the Rent(as % of GDP) in Austria in 1984 to that in 1986?
Ensure brevity in your answer.  2.07. What is the ratio of the Rent(as % of GDP) in Bangladesh in 1984 to that in 1986?
Provide a short and direct response. 1.1. What is the ratio of the Rent(as % of GDP) in Bulgaria in 1984 to that in 1986?
Provide a succinct answer. 3.97. What is the ratio of the Rent(as % of GDP) of Other small states in 1984 to that in 1987?
Your answer should be compact. 1.46. What is the ratio of the Rent(as % of GDP) in Austria in 1984 to that in 1987?
Provide a succinct answer. 3.6. What is the ratio of the Rent(as % of GDP) of Bangladesh in 1984 to that in 1987?
Your answer should be very brief. 1.46. What is the ratio of the Rent(as % of GDP) in Bulgaria in 1984 to that in 1987?
Offer a terse response. 10.34. What is the ratio of the Rent(as % of GDP) of Other small states in 1984 to that in 1988?
Keep it short and to the point. 1.32. What is the ratio of the Rent(as % of GDP) of Austria in 1984 to that in 1988?
Offer a terse response. 3.94. What is the ratio of the Rent(as % of GDP) of Bangladesh in 1984 to that in 1988?
Offer a terse response. 1.53. What is the ratio of the Rent(as % of GDP) of Bulgaria in 1984 to that in 1988?
Your answer should be very brief. 12.32. What is the ratio of the Rent(as % of GDP) of Other small states in 1985 to that in 1986?
Give a very brief answer. 1.06. What is the ratio of the Rent(as % of GDP) in Austria in 1985 to that in 1986?
Offer a terse response. 1.67. What is the ratio of the Rent(as % of GDP) of Bangladesh in 1985 to that in 1986?
Ensure brevity in your answer.  0.96. What is the ratio of the Rent(as % of GDP) of Bulgaria in 1985 to that in 1986?
Offer a terse response. 1.54. What is the ratio of the Rent(as % of GDP) of Other small states in 1985 to that in 1987?
Offer a terse response. 1.79. What is the ratio of the Rent(as % of GDP) in Austria in 1985 to that in 1987?
Your answer should be very brief. 2.91. What is the ratio of the Rent(as % of GDP) of Bangladesh in 1985 to that in 1987?
Give a very brief answer. 1.27. What is the ratio of the Rent(as % of GDP) of Bulgaria in 1985 to that in 1987?
Ensure brevity in your answer.  4.02. What is the ratio of the Rent(as % of GDP) of Other small states in 1985 to that in 1988?
Your response must be concise. 1.62. What is the ratio of the Rent(as % of GDP) of Austria in 1985 to that in 1988?
Offer a terse response. 3.19. What is the ratio of the Rent(as % of GDP) of Bangladesh in 1985 to that in 1988?
Make the answer very short. 1.34. What is the ratio of the Rent(as % of GDP) of Bulgaria in 1985 to that in 1988?
Your answer should be very brief. 4.79. What is the ratio of the Rent(as % of GDP) of Other small states in 1986 to that in 1987?
Provide a short and direct response. 1.68. What is the ratio of the Rent(as % of GDP) of Austria in 1986 to that in 1987?
Make the answer very short. 1.74. What is the ratio of the Rent(as % of GDP) of Bangladesh in 1986 to that in 1987?
Offer a terse response. 1.33. What is the ratio of the Rent(as % of GDP) in Bulgaria in 1986 to that in 1987?
Keep it short and to the point. 2.61. What is the ratio of the Rent(as % of GDP) of Other small states in 1986 to that in 1988?
Provide a succinct answer. 1.52. What is the ratio of the Rent(as % of GDP) in Austria in 1986 to that in 1988?
Offer a terse response. 1.91. What is the ratio of the Rent(as % of GDP) of Bangladesh in 1986 to that in 1988?
Give a very brief answer. 1.4. What is the ratio of the Rent(as % of GDP) of Bulgaria in 1986 to that in 1988?
Your answer should be very brief. 3.11. What is the ratio of the Rent(as % of GDP) of Other small states in 1987 to that in 1988?
Provide a succinct answer. 0.9. What is the ratio of the Rent(as % of GDP) of Austria in 1987 to that in 1988?
Provide a succinct answer. 1.1. What is the ratio of the Rent(as % of GDP) of Bangladesh in 1987 to that in 1988?
Give a very brief answer. 1.05. What is the ratio of the Rent(as % of GDP) in Bulgaria in 1987 to that in 1988?
Make the answer very short. 1.19. What is the difference between the highest and the second highest Rent(as % of GDP) in Other small states?
Your answer should be compact. 0.03. What is the difference between the highest and the second highest Rent(as % of GDP) of Austria?
Make the answer very short. 0.02. What is the difference between the highest and the second highest Rent(as % of GDP) of Bangladesh?
Your response must be concise. 0.05. What is the difference between the highest and the lowest Rent(as % of GDP) of Other small states?
Offer a terse response. 0.1. What is the difference between the highest and the lowest Rent(as % of GDP) of Austria?
Your answer should be compact. 0.15. What is the difference between the highest and the lowest Rent(as % of GDP) of Bangladesh?
Offer a terse response. 0.44. What is the difference between the highest and the lowest Rent(as % of GDP) of Bulgaria?
Your response must be concise. 0.04. 